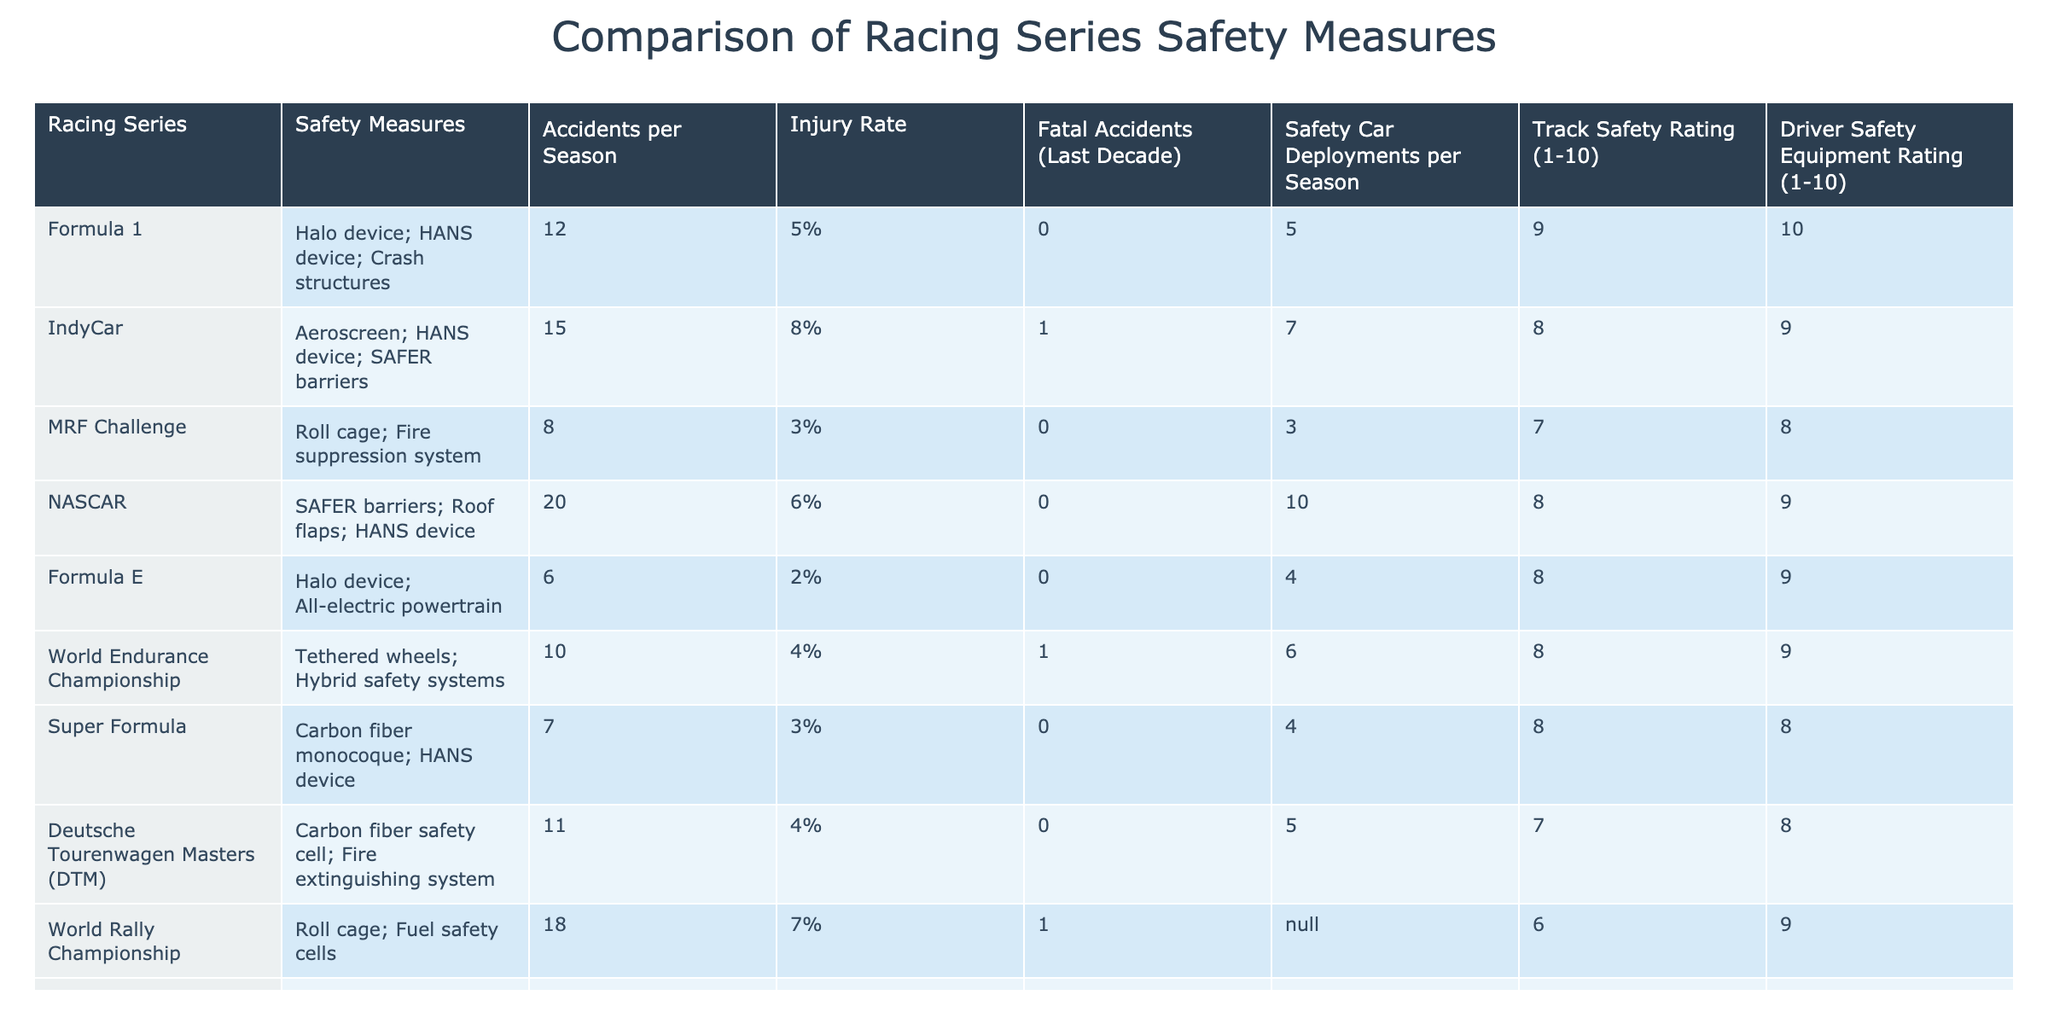What is the injury rate of MotoGP? The injury rate is specifically listed in the table under the "Injury Rate" column for MotoGP, which shows 12%.
Answer: 12% Which racing series has the highest number of accidents per season? By analyzing the "Accidents per Season" column, we see that NASCAR has the highest number at 20 accidents.
Answer: NASCAR Are there any racing series with zero fatal accidents in the last decade? Looking at the "Fatal Accidents (Last Decade)" column, we see that Formula 1, MRF Challenge, NASCAR, Formula E, Super Formula, and Deutsche Tourenwagen Masters all have 0 fatal accidents, indicating that they experienced no fatalities in the last decade.
Answer: Yes What is the average injury rate of all racing series listed in the table? We sum the injury rates: 5% + 8% + 3% + 6% + 2% + 4% + 3% + 4% + 7% + 12% = 54%. There are 10 series, so the average is 54% / 10 = 5.4%.
Answer: 5.4% Which racing series has the highest track safety rating? The "Track Safety Rating" column shows that Formula 1 has the highest rating of 10.
Answer: Formula 1 How many racing series have a safety car deployment rate of 5 or more per season? By reviewing the "Safety Car Deployments per Season" column, it reveals that IndyCar (7), NASCAR (10), and World Rally Championship (N/A) are the only series that meet this criterion since we exclude those with N/A. Therefore, there are two that strictly have numbers equal to or greater than 5.
Answer: 2 Is the safety equipment rating higher in Formula E than in Super Formula? The table shows a rating of 9 for Formula E and 8 for Super Formula in the "Driver Safety Equipment Rating" column; thus, Formula E has a higher safety equipment rating.
Answer: Yes What is the difference in accidents per season between Formula E and World Rally Championship? Formula E has 6 accidents per season and World Rally Championship has 18, so the difference is 18 - 6 = 12 accidents.
Answer: 12 